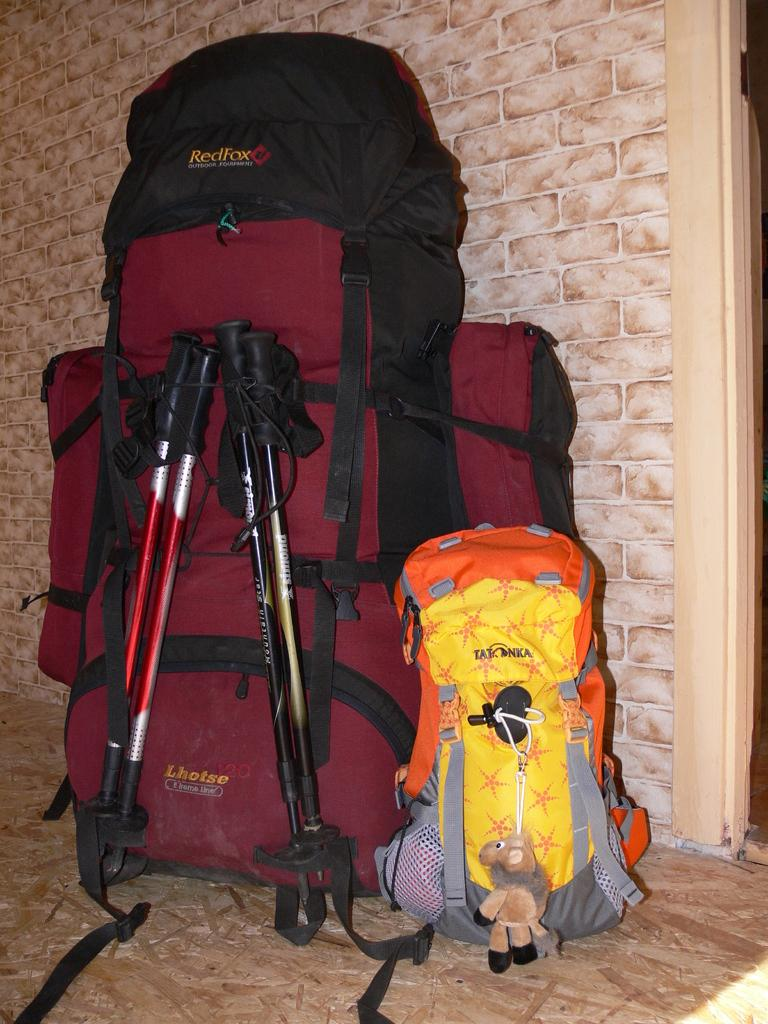<image>
Offer a succinct explanation of the picture presented. a red bag with Lhotse written on it 